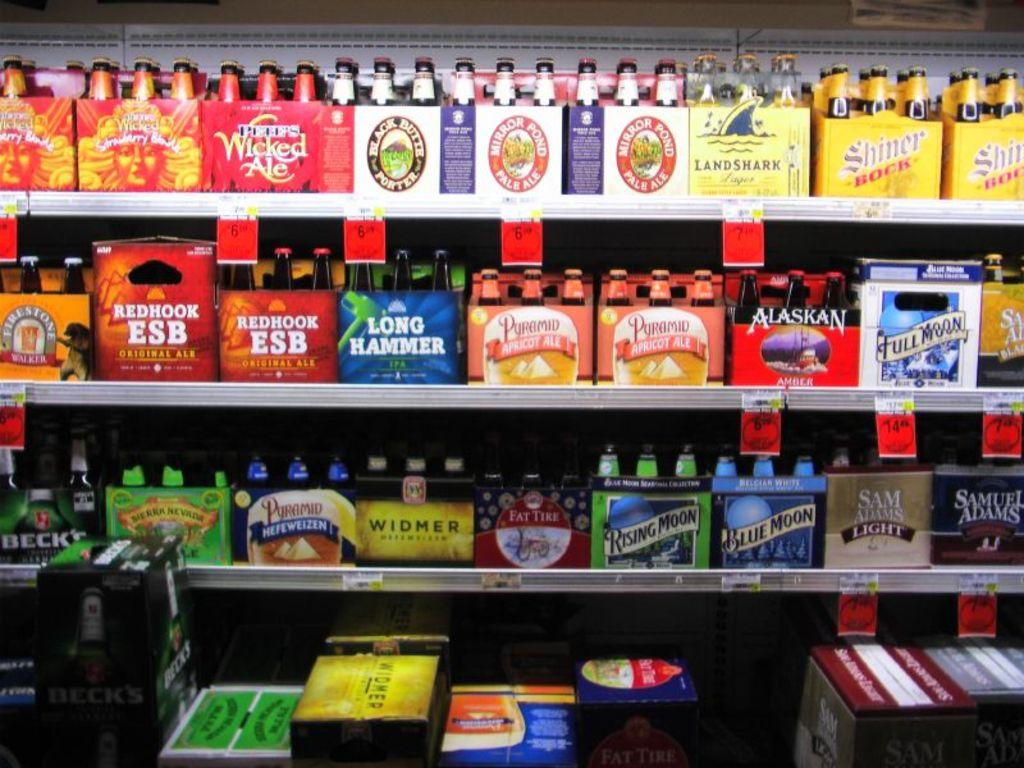Provide a one-sentence caption for the provided image. A grocery shelf shows several beer cartons on shelves including Full Moon among other brands. 